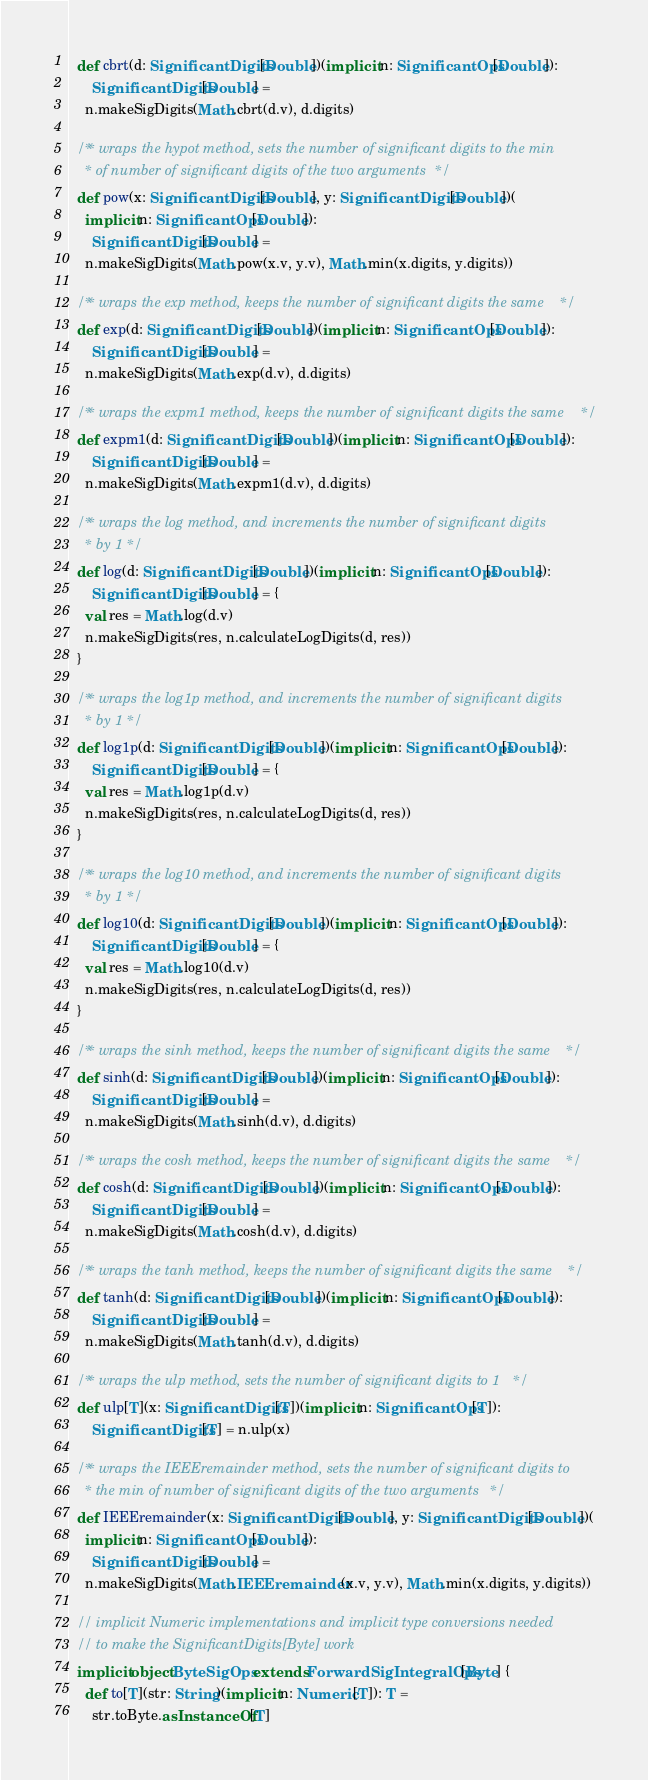Convert code to text. <code><loc_0><loc_0><loc_500><loc_500><_Scala_>  def cbrt(d: SignificantDigits[Double])(implicit n: SignificantOps[Double]):
      SignificantDigits[Double] = 
    n.makeSigDigits(Math.cbrt(d.v), d.digits)

  /** wraps the hypot method, sets the number of significant digits to the min
    * of number of significant digits of the two arguments */
  def pow(x: SignificantDigits[Double], y: SignificantDigits[Double])(
    implicit n: SignificantOps[Double]): 
      SignificantDigits[Double] =
    n.makeSigDigits(Math.pow(x.v, y.v), Math.min(x.digits, y.digits))

  /** wraps the exp method, keeps the number of significant digits the same */
  def exp(d: SignificantDigits[Double])(implicit n: SignificantOps[Double]):
      SignificantDigits[Double] =
    n.makeSigDigits(Math.exp(d.v), d.digits)

  /** wraps the expm1 method, keeps the number of significant digits the same */
  def expm1(d: SignificantDigits[Double])(implicit n: SignificantOps[Double]):
      SignificantDigits[Double] =
    n.makeSigDigits(Math.expm1(d.v), d.digits)

  /** wraps the log method, and increments the number of significant digits 
    * by 1 */
  def log(d: SignificantDigits[Double])(implicit n: SignificantOps[Double]):
      SignificantDigits[Double] = {
    val res = Math.log(d.v)
    n.makeSigDigits(res, n.calculateLogDigits(d, res))
  }

  /** wraps the log1p method, and increments the number of significant digits 
    * by 1 */
  def log1p(d: SignificantDigits[Double])(implicit n: SignificantOps[Double]):
      SignificantDigits[Double] = {
    val res = Math.log1p(d.v)
    n.makeSigDigits(res, n.calculateLogDigits(d, res))
  }

  /** wraps the log10 method, and increments the number of significant digits 
    * by 1 */
  def log10(d: SignificantDigits[Double])(implicit n: SignificantOps[Double]):
      SignificantDigits[Double] = {
    val res = Math.log10(d.v)
    n.makeSigDigits(res, n.calculateLogDigits(d, res))
  }

  /** wraps the sinh method, keeps the number of significant digits the same */
  def sinh(d: SignificantDigits[Double])(implicit n: SignificantOps[Double]):
      SignificantDigits[Double] =
    n.makeSigDigits(Math.sinh(d.v), d.digits)

  /** wraps the cosh method, keeps the number of significant digits the same */
  def cosh(d: SignificantDigits[Double])(implicit n: SignificantOps[Double]):
      SignificantDigits[Double] =
    n.makeSigDigits(Math.cosh(d.v), d.digits)

  /** wraps the tanh method, keeps the number of significant digits the same */
  def tanh(d: SignificantDigits[Double])(implicit n: SignificantOps[Double]):
      SignificantDigits[Double] =
    n.makeSigDigits(Math.tanh(d.v), d.digits)

  /** wraps the ulp method, sets the number of significant digits to 1 */
  def ulp[T](x: SignificantDigits[T])(implicit n: SignificantOps[T]):
      SignificantDigits[T] = n.ulp(x)

  /** wraps the IEEEremainder method, sets the number of significant digits to 
    * the min of number of significant digits of the two arguments */
  def IEEEremainder(x: SignificantDigits[Double], y: SignificantDigits[Double])(
    implicit n: SignificantOps[Double]): 
      SignificantDigits[Double] =
    n.makeSigDigits(Math.IEEEremainder(x.v, y.v), Math.min(x.digits, y.digits))

  // implicit Numeric implementations and implicit type conversions needed
  // to make the SignificantDigits[Byte] work
  implicit object ByteSigOps extends ForwardSigIntegralOps[Byte] {
    def to[T](str: String)(implicit n: Numeric[T]): T =
      str.toByte.asInstanceOf[T]</code> 